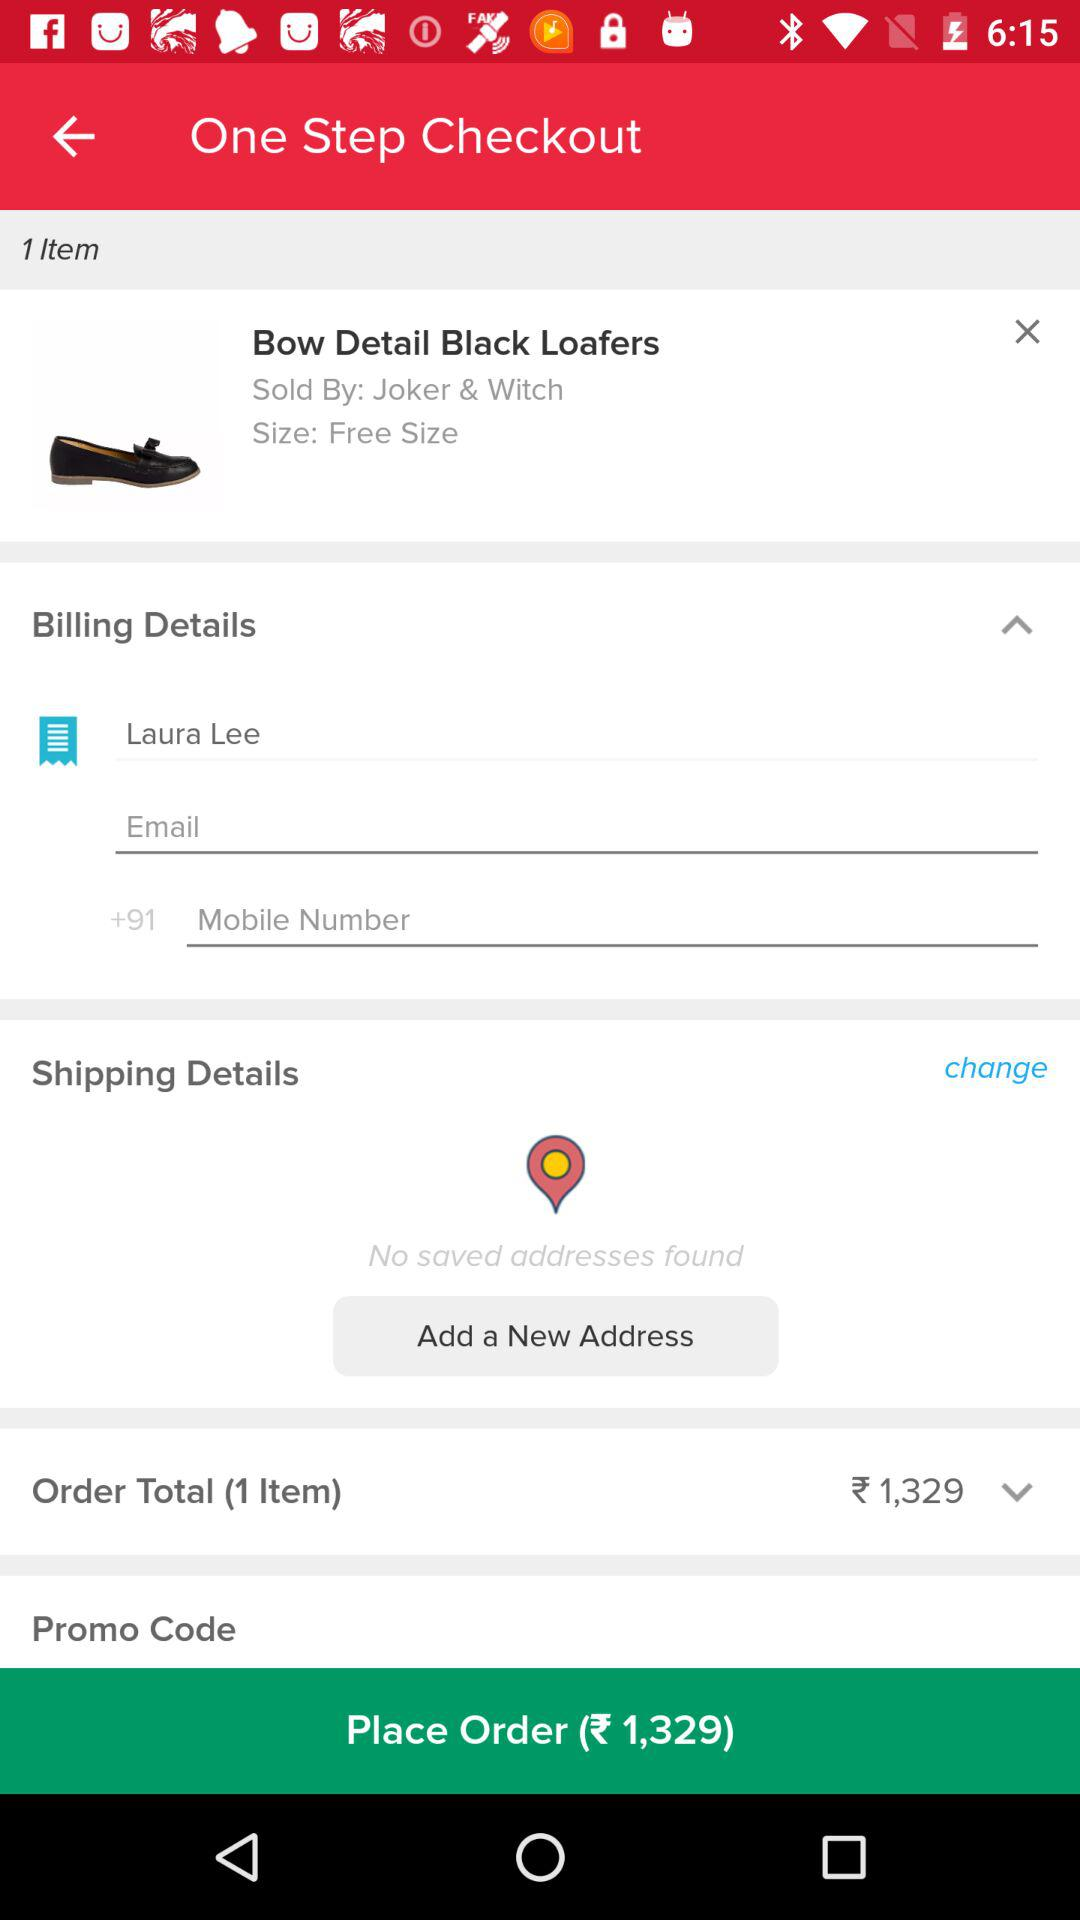What is the size of the shoes? The size of the shoes is "Free Size". 